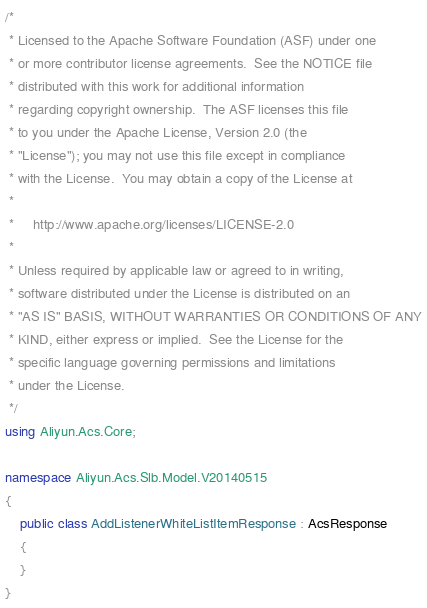<code> <loc_0><loc_0><loc_500><loc_500><_C#_>/*
 * Licensed to the Apache Software Foundation (ASF) under one
 * or more contributor license agreements.  See the NOTICE file
 * distributed with this work for additional information
 * regarding copyright ownership.  The ASF licenses this file
 * to you under the Apache License, Version 2.0 (the
 * "License"); you may not use this file except in compliance
 * with the License.  You may obtain a copy of the License at
 *
 *     http://www.apache.org/licenses/LICENSE-2.0
 *
 * Unless required by applicable law or agreed to in writing,
 * software distributed under the License is distributed on an
 * "AS IS" BASIS, WITHOUT WARRANTIES OR CONDITIONS OF ANY
 * KIND, either express or implied.  See the License for the
 * specific language governing permissions and limitations
 * under the License.
 */
using Aliyun.Acs.Core;

namespace Aliyun.Acs.Slb.Model.V20140515
{
	public class AddListenerWhiteListItemResponse : AcsResponse
	{
	}
}</code> 